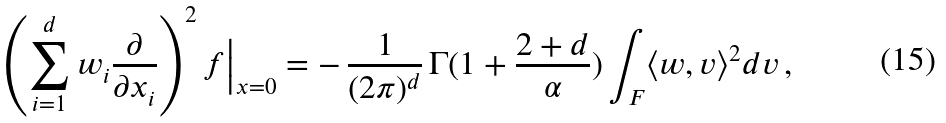Convert formula to latex. <formula><loc_0><loc_0><loc_500><loc_500>\left ( \sum _ { i = 1 } ^ { d } w _ { i } \frac { \partial } { \partial x _ { i } } \right ) ^ { 2 } f \Big | _ { x = 0 } = - \, \frac { 1 } { ( 2 \pi ) ^ { d } } \, \Gamma ( 1 + \frac { 2 + d } { \alpha } ) \int _ { F } \langle w , v \rangle ^ { 2 } d v \, ,</formula> 